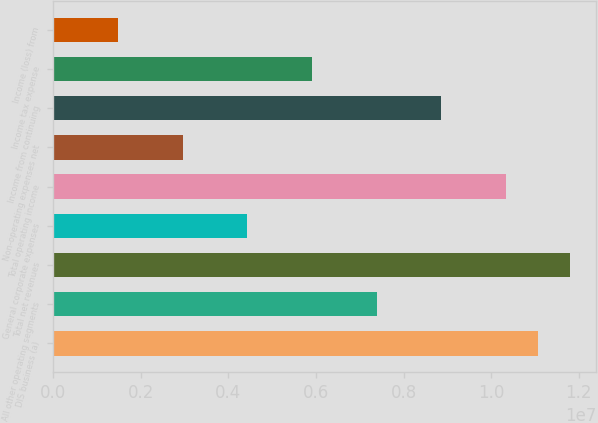<chart> <loc_0><loc_0><loc_500><loc_500><bar_chart><fcel>DIS business (a)<fcel>All other operating segments<fcel>Total net revenues<fcel>General corporate expenses<fcel>Total operating income<fcel>Non-operating expenses net<fcel>Income from continuing<fcel>Income tax expense<fcel>Income (loss) from<nl><fcel>1.10697e+07<fcel>7.38256e+06<fcel>1.18071e+07<fcel>4.43286e+06<fcel>1.03323e+07<fcel>2.95801e+06<fcel>8.85741e+06<fcel>5.90771e+06<fcel>1.48316e+06<nl></chart> 